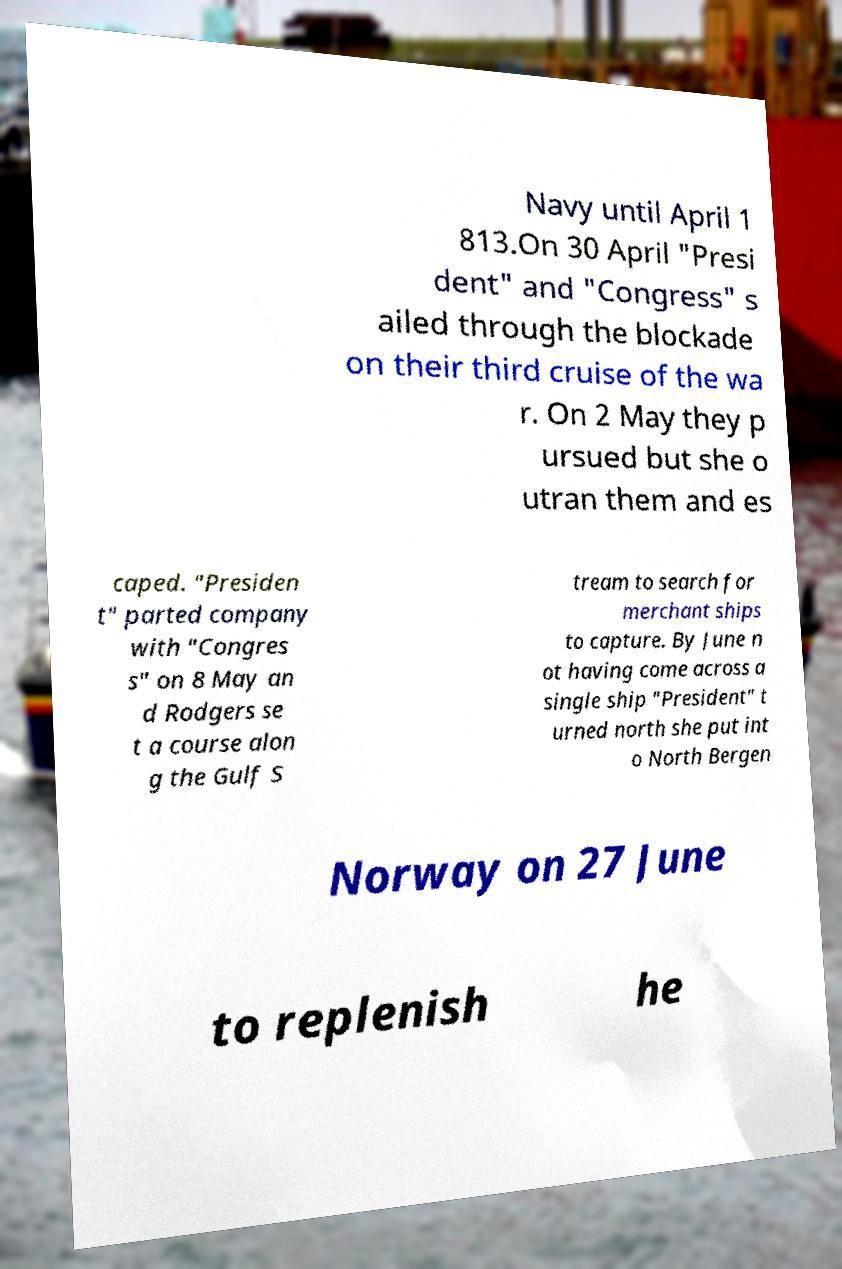For documentation purposes, I need the text within this image transcribed. Could you provide that? Navy until April 1 813.On 30 April "Presi dent" and "Congress" s ailed through the blockade on their third cruise of the wa r. On 2 May they p ursued but she o utran them and es caped. "Presiden t" parted company with "Congres s" on 8 May an d Rodgers se t a course alon g the Gulf S tream to search for merchant ships to capture. By June n ot having come across a single ship "President" t urned north she put int o North Bergen Norway on 27 June to replenish he 